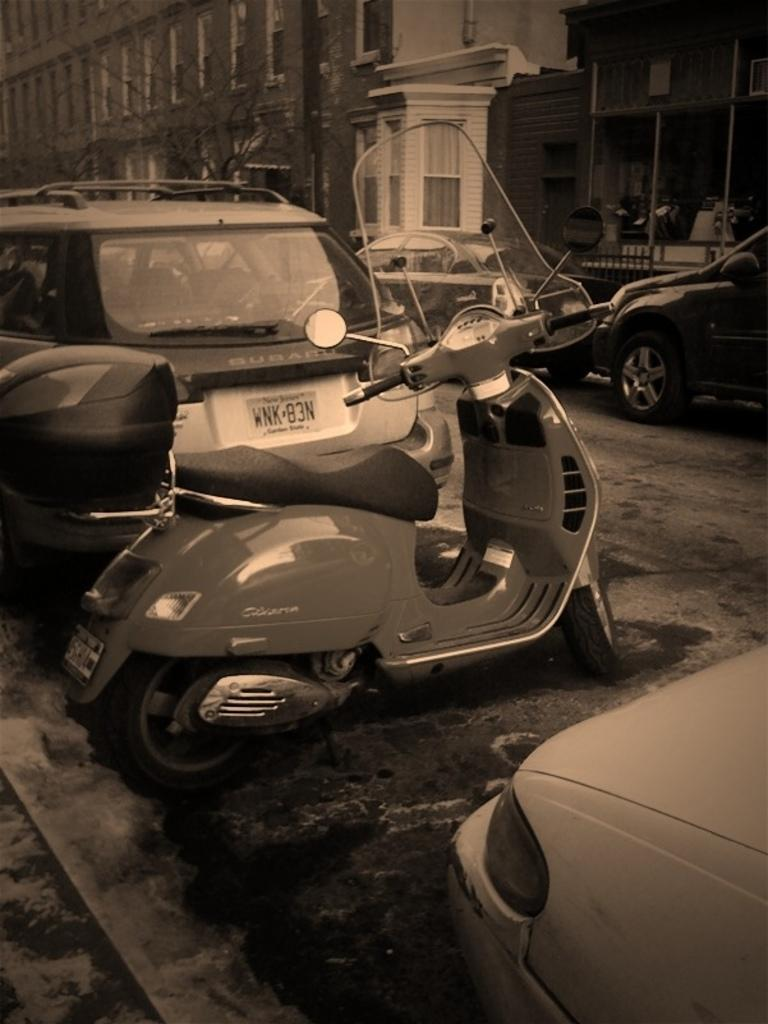What is the color scheme of the image? The image is black and white. What types of man-made structures can be seen in the image? There are buildings in the image. What types of transportation are visible in the image? There are vehicles in the image. What type of natural vegetation is present in the image? There are trees in the image. What else can be seen in the image besides the mentioned elements? There are objects in the image. What type of toy can be seen playing with a memory in the image? There is no toy or memory present in the image; it is a black and white image featuring buildings, vehicles, trees, and other objects. 